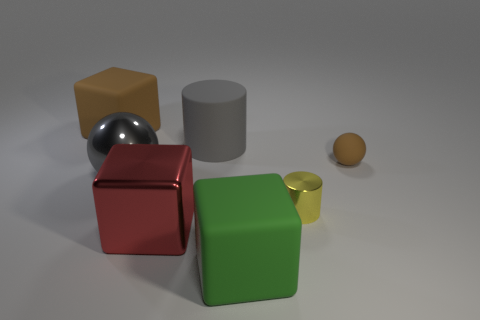Add 1 big gray rubber cylinders. How many objects exist? 8 Subtract all cubes. How many objects are left? 4 Subtract all gray things. Subtract all metal cubes. How many objects are left? 4 Add 6 small cylinders. How many small cylinders are left? 7 Add 5 small yellow objects. How many small yellow objects exist? 6 Subtract 0 red cylinders. How many objects are left? 7 